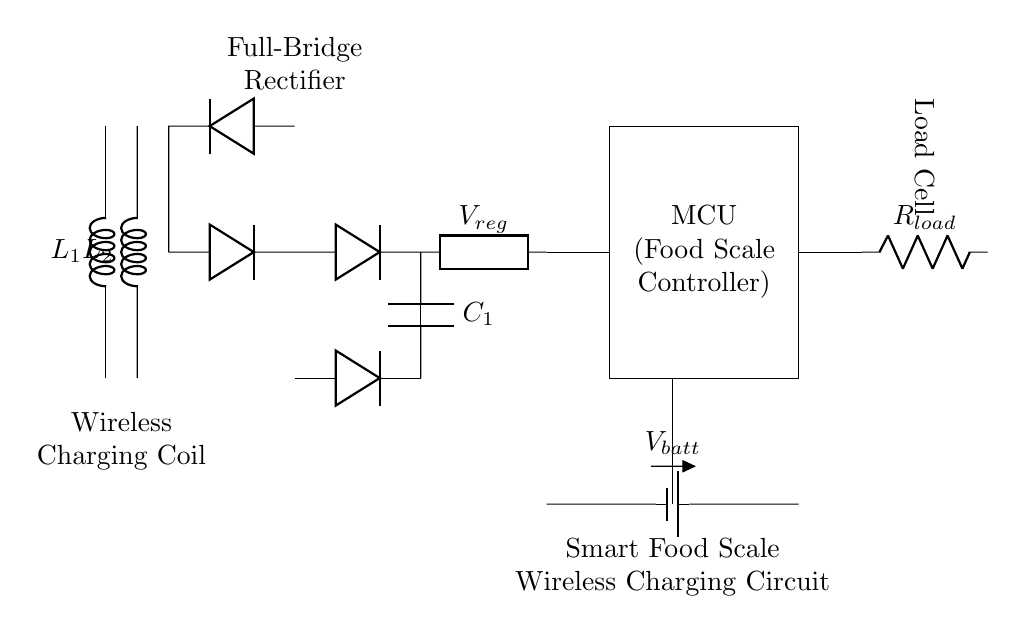What type of components are used in the rectifier section? The rectifier section consists of diodes, specifically four diodes arranged in a full-bridge configuration to convert AC to DC.
Answer: Diodes What is the purpose of the smoothing capacitor? The smoothing capacitor is used to reduce the ripple voltage in the output of the rectifier, providing a steadier DC voltage to the subsequent components.
Answer: Smoothing How many inductors are present in the circuit? There are two inductors, labeled L1 and L2, located at the beginning of the circuit, forming the wireless charging coil section.
Answer: Two What is the output voltage regulator component labeled as? The component that regulates output voltage is labeled as V_reg in the circuit diagram, providing a stable voltage to the microcontroller.
Answer: V_reg What does the MCU in the circuit diagram stand for? MCU stands for Microcontroller Unit, which serves as the central controller for the smart food scale, processing measurements and user inputs.
Answer: Microcontroller Unit What type of load is being measured in the circuit? The load being measured is indicated by a load cell, represented by R_load in the circuit, which is typically used for weight measurements.
Answer: Load Cell What is the voltage source used in this circuit diagram? The voltage source in the diagram is labeled V_batt, indicating it is a battery supplying power to the circuit components.
Answer: Battery 